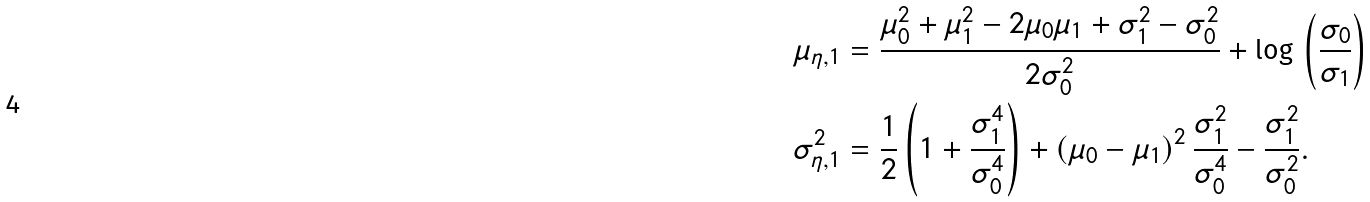Convert formula to latex. <formula><loc_0><loc_0><loc_500><loc_500>\mu _ { \eta , 1 } & = \frac { \mu _ { 0 } ^ { 2 } + \mu _ { 1 } ^ { 2 } - 2 \mu _ { 0 } \mu _ { 1 } + \sigma _ { 1 } ^ { 2 } - \sigma _ { 0 } ^ { 2 } } { 2 \sigma _ { 0 } ^ { 2 } } + \log \, \left ( \frac { \sigma _ { 0 } } { \sigma _ { 1 } } \right ) \\ \sigma _ { \eta , 1 } ^ { 2 } & = \frac { 1 } { 2 } \left ( 1 + \frac { \sigma _ { 1 } ^ { 4 } } { \sigma _ { 0 } ^ { 4 } } \right ) + \left ( \mu _ { 0 } - \mu _ { 1 } \right ) ^ { 2 } \frac { \sigma _ { 1 } ^ { 2 } } { \sigma _ { 0 } ^ { 4 } } - \frac { \sigma _ { 1 } ^ { 2 } } { \sigma _ { 0 } ^ { 2 } } .</formula> 